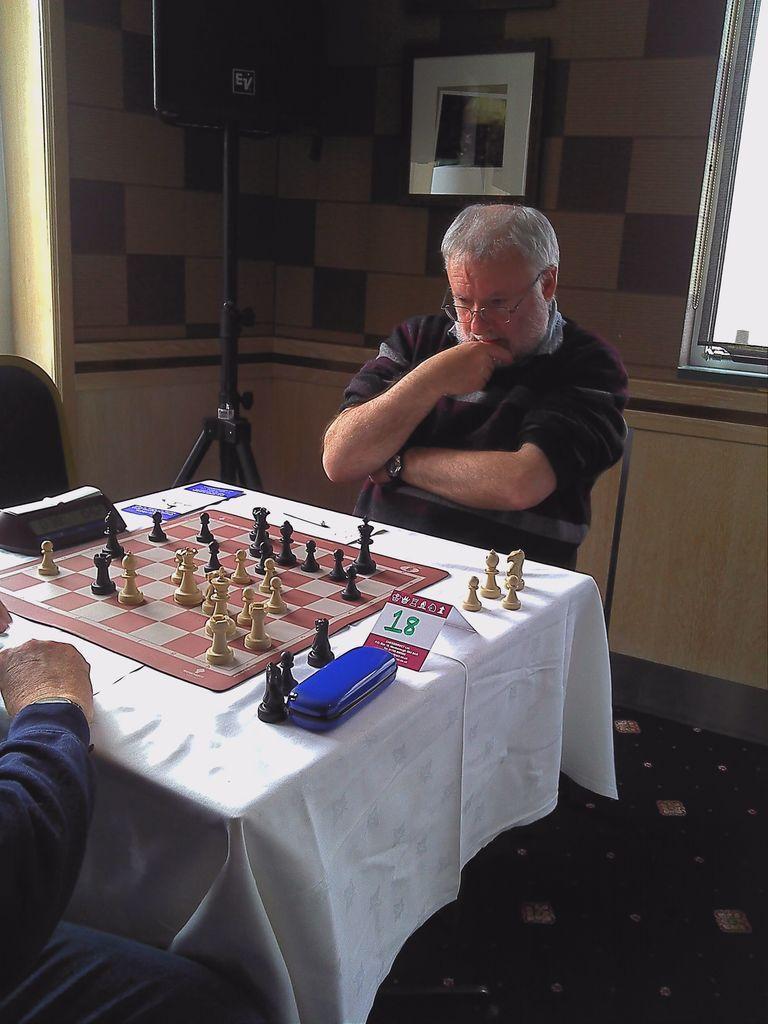In one or two sentences, can you explain what this image depicts? In this image I can see two persons sitting. In front of them there is a table and the chess board on it. At the back side there is a frame attached to the wall. 